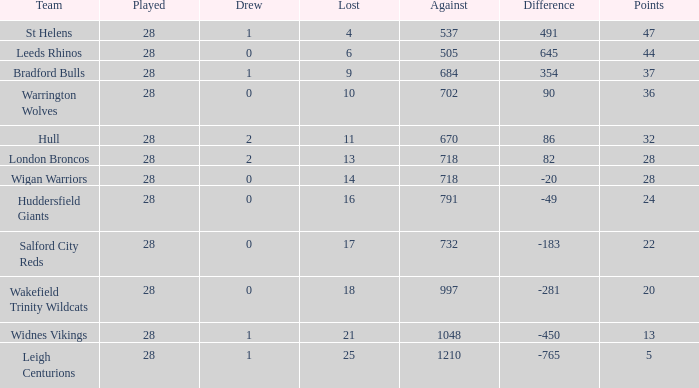What is the most lost games for the team with a difference smaller than 86 and points of 32? None. 